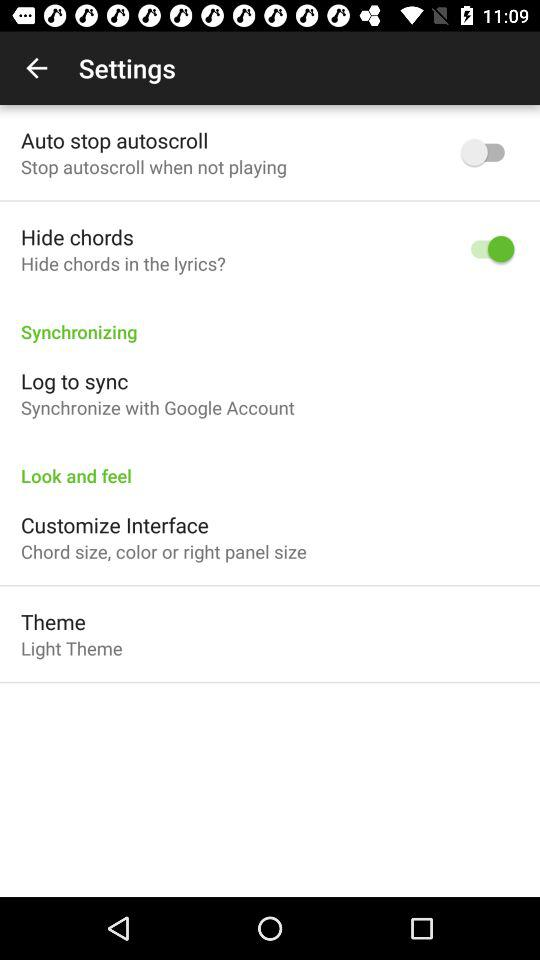How many settings items have a switch?
Answer the question using a single word or phrase. 2 